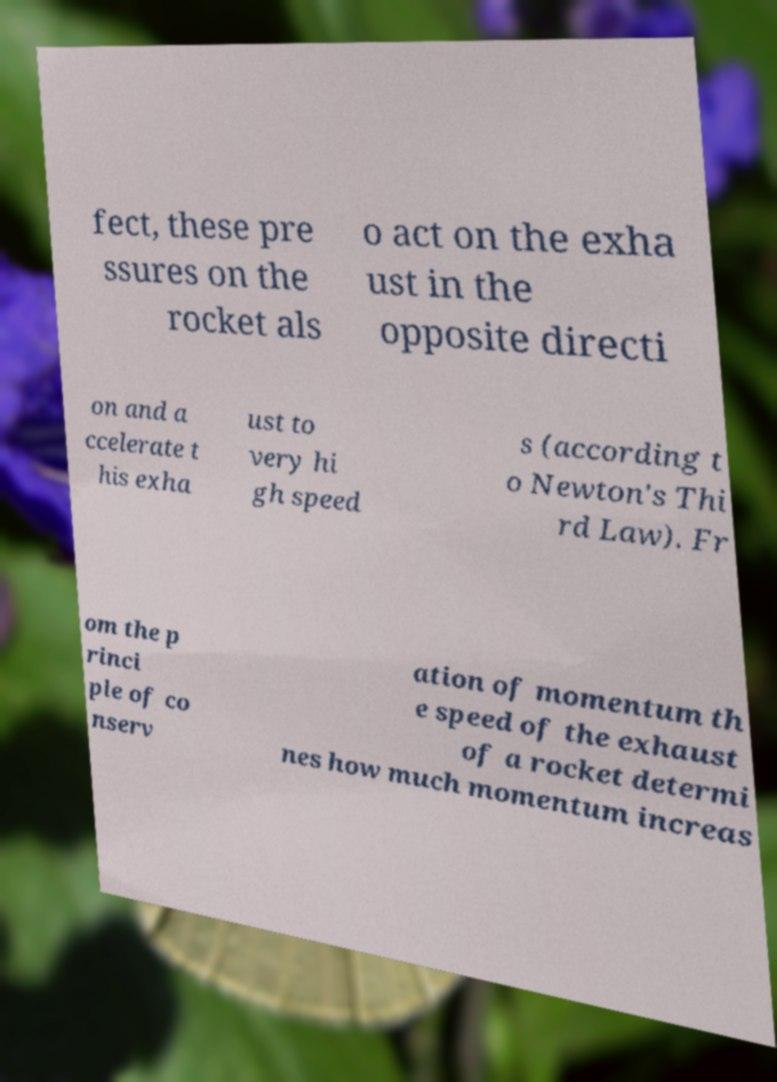Can you accurately transcribe the text from the provided image for me? fect, these pre ssures on the rocket als o act on the exha ust in the opposite directi on and a ccelerate t his exha ust to very hi gh speed s (according t o Newton's Thi rd Law). Fr om the p rinci ple of co nserv ation of momentum th e speed of the exhaust of a rocket determi nes how much momentum increas 